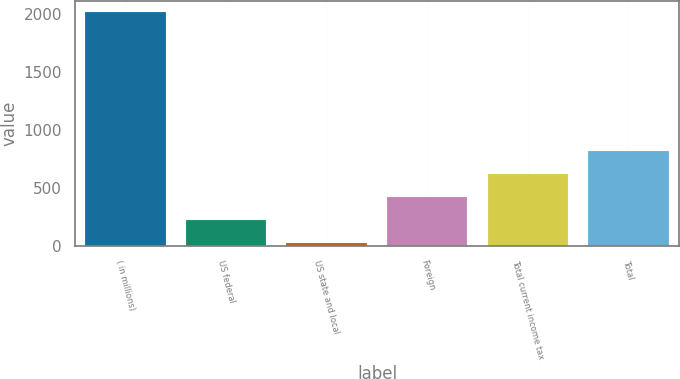<chart> <loc_0><loc_0><loc_500><loc_500><bar_chart><fcel>( in millions)<fcel>US federal<fcel>US state and local<fcel>Foreign<fcel>Total current income tax<fcel>Total<nl><fcel>2015<fcel>221.3<fcel>22<fcel>420.6<fcel>619.9<fcel>819.2<nl></chart> 